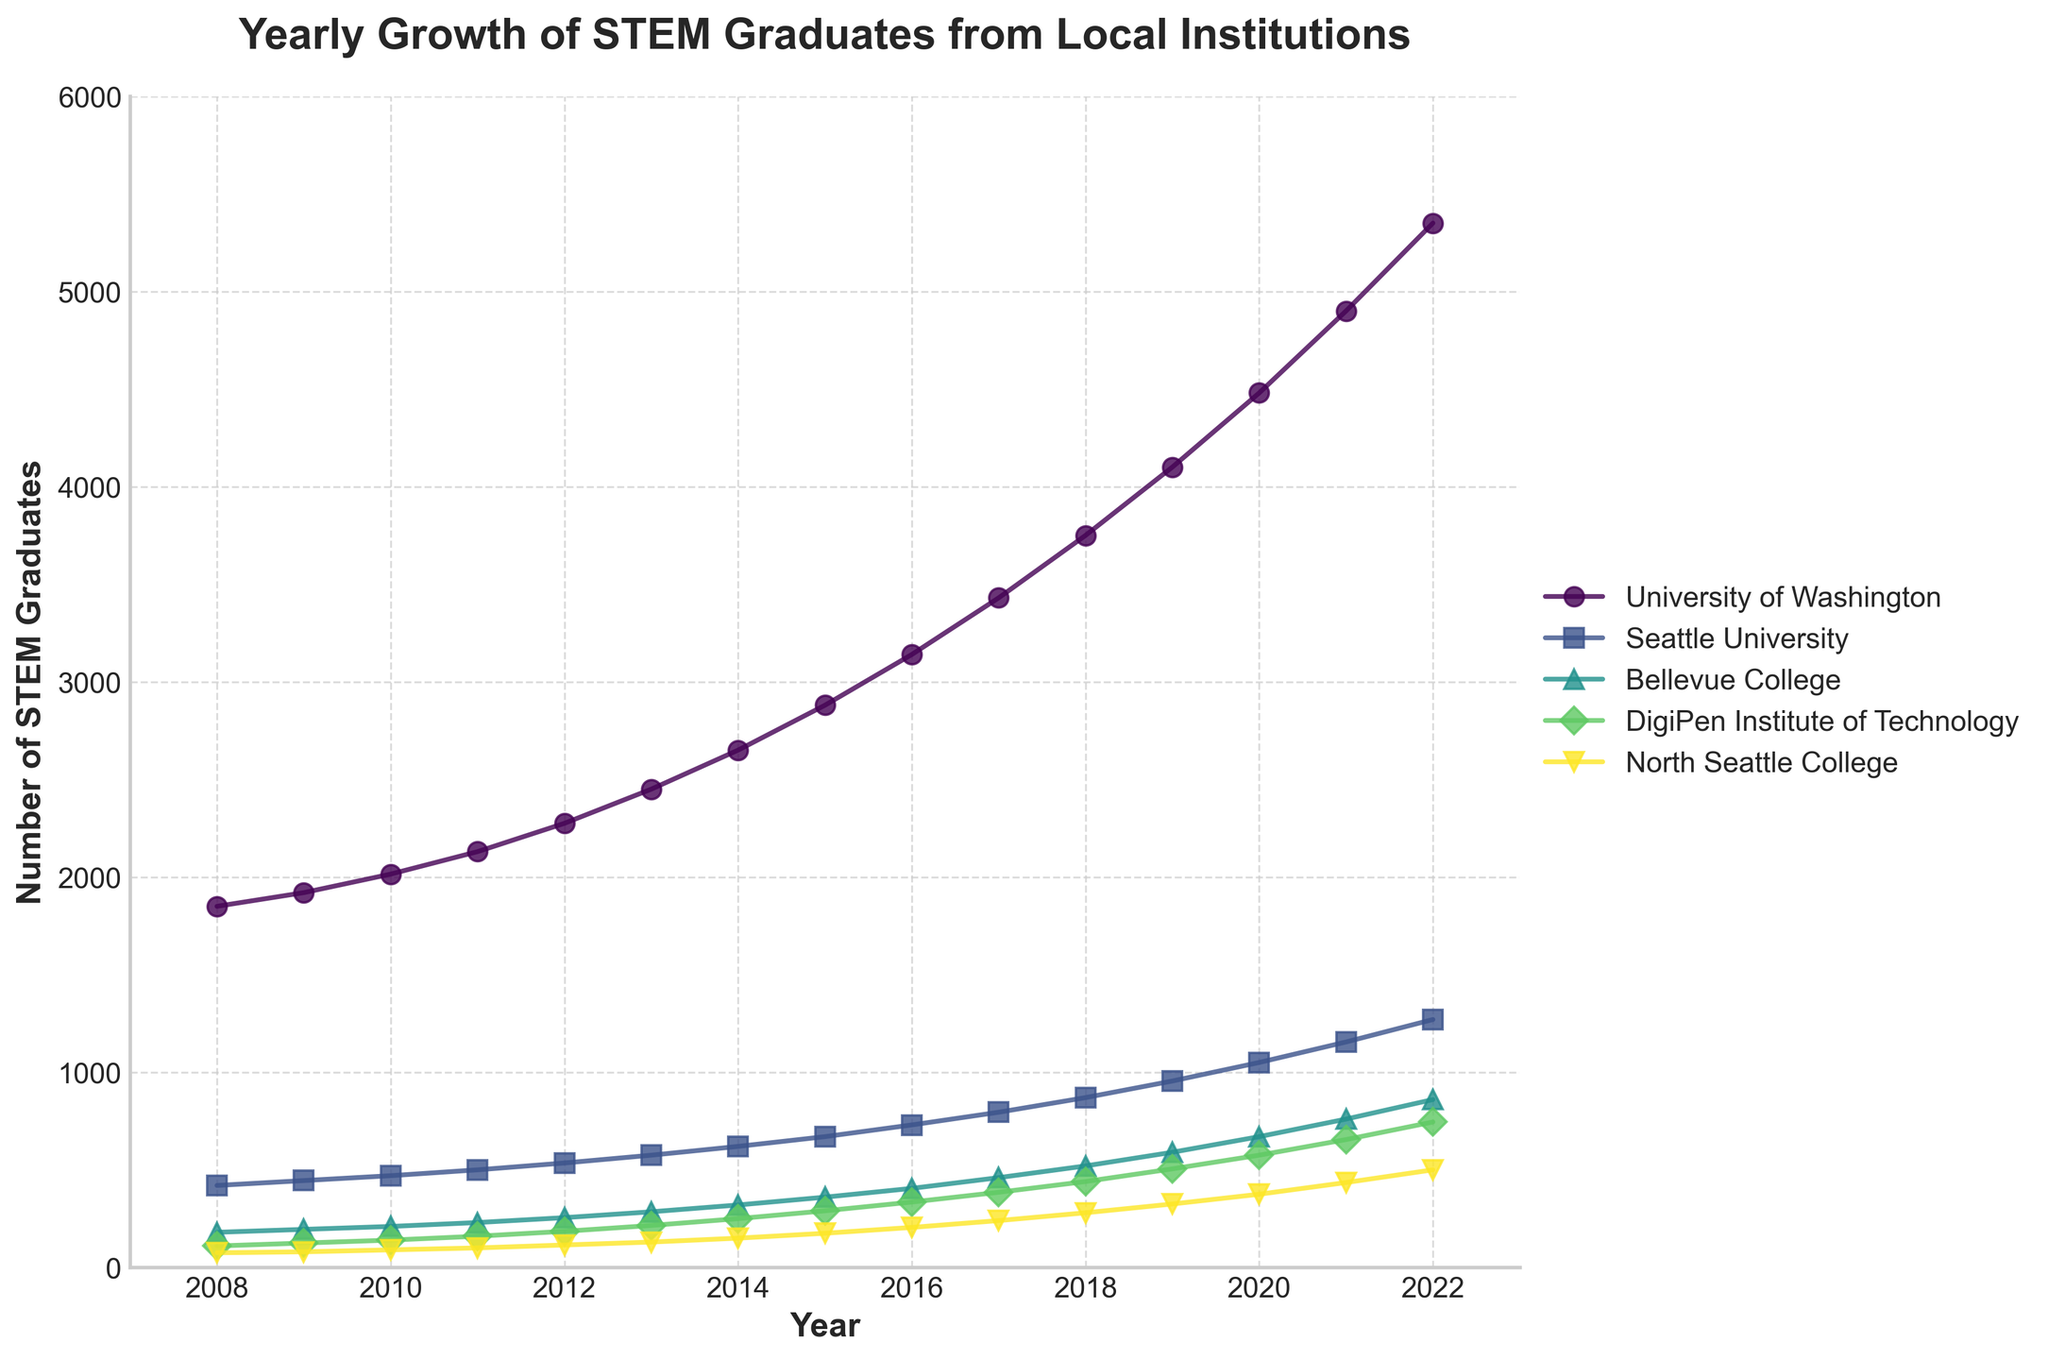What's the overall trend in the number of STEM graduates from the University of Washington over the 15 years? The overall trend can be observed by examining the line representing the University of Washington from 2008 to 2022. The line consistently rises, indicating a continuous increase in the number of STEM graduates over the 15-year period.
Answer: An increasing trend In which year did Bellevue College see the largest increase in STEM graduates from the previous year? To find the largest increase, look at the differences between successive years' data points for Bellevue College. The largest jump is from 2018 (520) to 2019 (590), an increase of 70.
Answer: Between 2018 and 2019 Which institution had the fastest annual growth rate in STEM graduates in 2021? To determine the fastest growth rate for 2021, compare the year-over-year growth from 2020 to 2021 for all institutions. North Seattle College’s growth from 375 to 435 is a significant percentage change relative to its size.
Answer: North Seattle College What was the total number of STEM graduates from all institutions in 2015? Sum the number of STEM graduates from all institutions in 2015 (University of Washington: 2880, Seattle University: 670, Bellevue College: 360, DigiPen: 290, North Seattle College: 175). Adding these together, 2880 + 670 + 360 + 290 + 175 = 4375.
Answer: 4375 Which two institutions had the closest number of STEM graduates in 2012? Observe the values for all institutions in 2012 and find those closest in number. Bellevue College (255) and DigiPen (185) are closest.
Answer: Bellevue College and DigiPen How many more STEM graduates were there in 2022 compared to 2008 for the University of Washington? Subtract the number of graduates in 2008 (1850) from the number in 2022 (5350). The difference is 5350 - 1850 = 3500.
Answer: 3500 more graduates From 2018 to 2020, which institution had the highest absolute increase in the number of STEM graduates? Compare increases for all institutions over these two years. University of Washington increased from 3750 (2018) to 4480 (2020), an increase of 4480 - 3750 = 730. This is the highest among all institutions.
Answer: University of Washington Is there any year where all institutions increased their number of STEM graduates compared to the previous year? Verify each year from 2008 to 2022 to see if the values for all institutions increased compared to the previous year. For example, in 2010, all institutions increased their numbers from their 2009 values.
Answer: 2010 By what percentage did Seattle University increase its STEM graduates from 2008 to 2022? Calculate the percentage increase: [(1270 - 420) / 420] * 100. This gives [(1270 - 420) / 420] * 100 = 202.38%.
Answer: 202.38% 